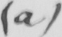Can you read and transcribe this handwriting? ( a ) 